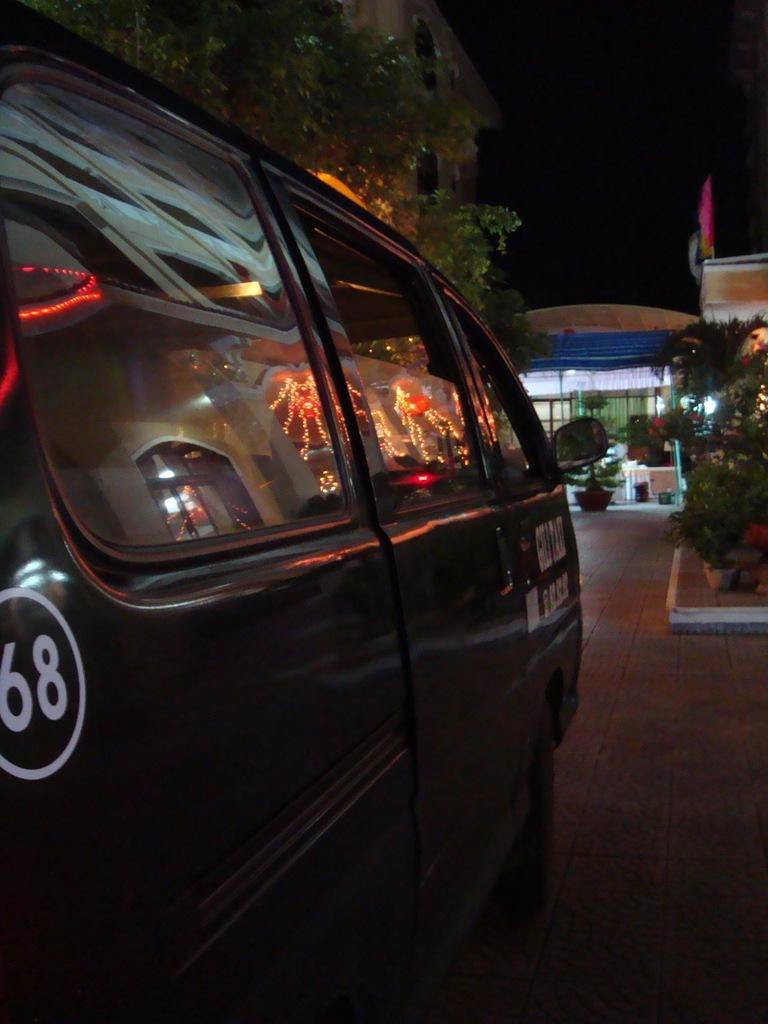Can you describe this image briefly? In this picture we can see a vehicle on the path and behind the vehicle there are trees, plants and a house. Behind the house there is a dark background. 